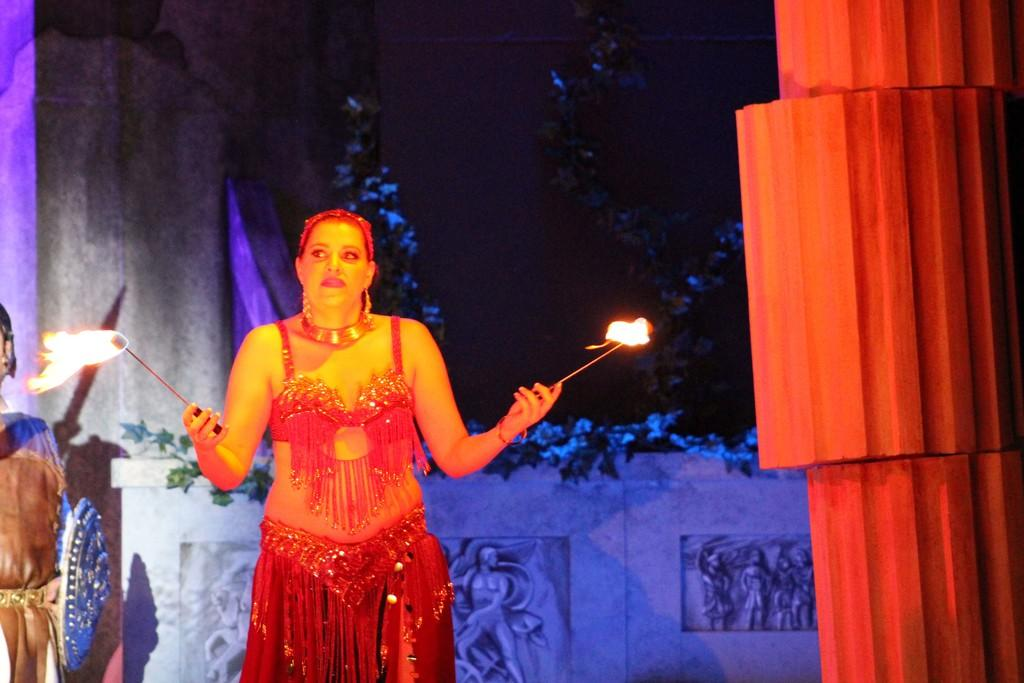What is the woman in the image holding? The woman is holding fire sticks in the image. What other objects or features can be seen in the image? There are sculptures, plants, a pillar, and trees in the background of the image. Can you describe the plants in the image? The plants are not specifically described in the facts, but they are mentioned as being present in the image. What type of structure is the pillar in the image? The facts do not specify the type of pillar, but it is mentioned as being present in the image. What type of bird can be seen flying near the trees in the background of the image? There is no bird visible in the image; only the trees in the background are mentioned. 